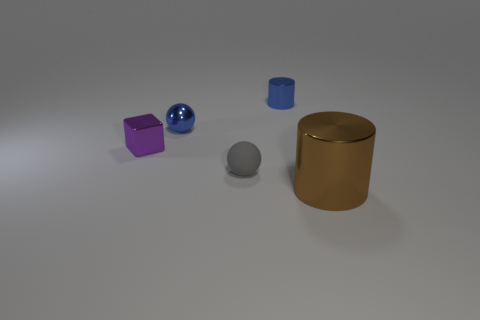What is the size of the blue cylinder?
Ensure brevity in your answer.  Small. What number of other objects are the same color as the tiny metal sphere?
Offer a terse response. 1. There is a object that is both right of the gray ball and in front of the small purple object; what is its color?
Your answer should be compact. Brown. What number of big brown shiny objects are there?
Give a very brief answer. 1. Do the small block and the gray ball have the same material?
Provide a succinct answer. No. There is a blue object left of the shiny cylinder that is left of the metallic cylinder that is in front of the blue shiny sphere; what is its shape?
Offer a very short reply. Sphere. Are the cylinder behind the brown cylinder and the tiny sphere that is in front of the shiny ball made of the same material?
Offer a terse response. No. What is the gray sphere made of?
Your answer should be compact. Rubber. What number of small metallic objects have the same shape as the large brown metallic object?
Keep it short and to the point. 1. What material is the tiny object that is the same color as the small metallic cylinder?
Provide a succinct answer. Metal. 